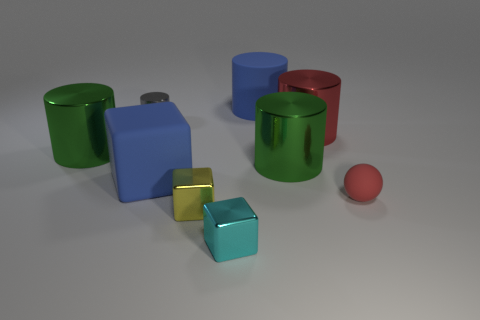Subtract all purple cylinders. Subtract all cyan cubes. How many cylinders are left? 5 Subtract all cylinders. How many objects are left? 4 Add 3 gray metallic objects. How many gray metallic objects exist? 4 Subtract 0 yellow spheres. How many objects are left? 9 Subtract all tiny rubber things. Subtract all cyan shiny things. How many objects are left? 7 Add 2 cyan shiny blocks. How many cyan shiny blocks are left? 3 